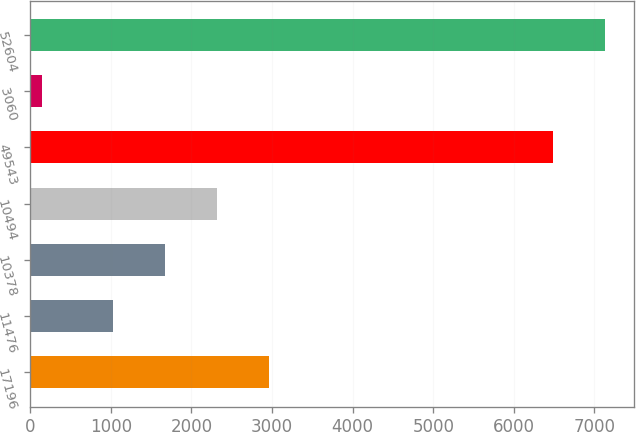Convert chart. <chart><loc_0><loc_0><loc_500><loc_500><bar_chart><fcel>17196<fcel>11476<fcel>10378<fcel>10494<fcel>49543<fcel>3060<fcel>52604<nl><fcel>2967.17<fcel>1022.9<fcel>1670.99<fcel>2319.08<fcel>6481<fcel>143<fcel>7129.09<nl></chart> 